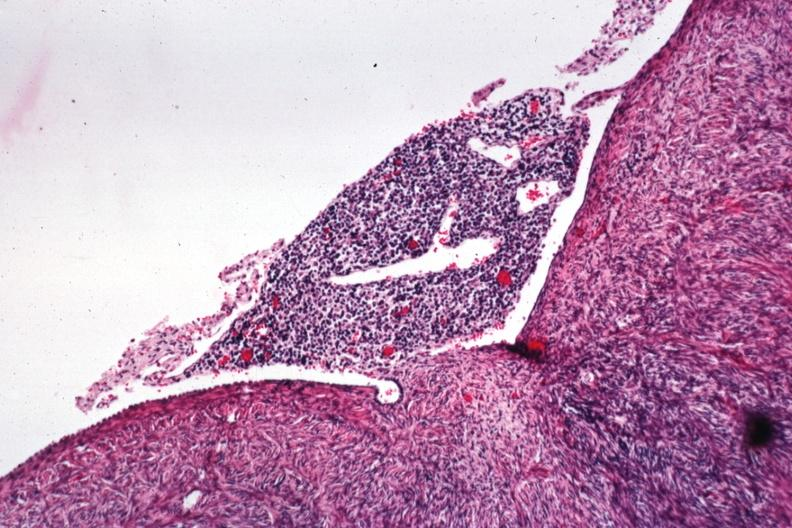what is present?
Answer the question using a single word or phrase. Malignant lymphoma 